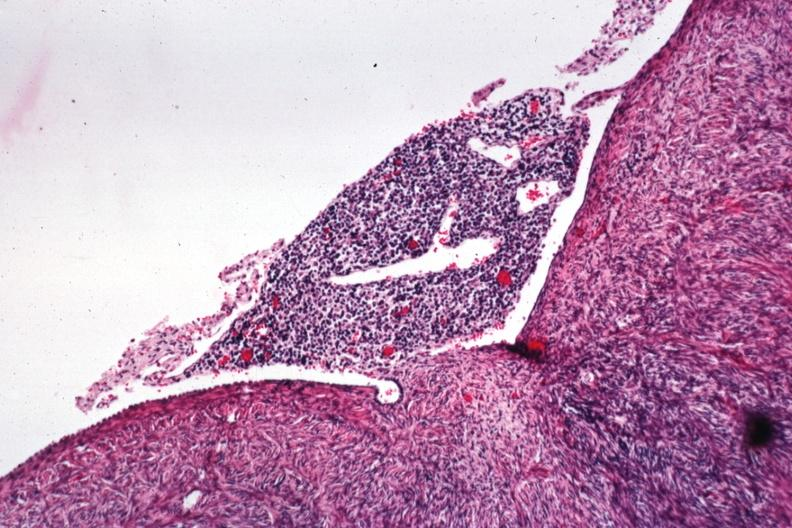what is present?
Answer the question using a single word or phrase. Malignant lymphoma 